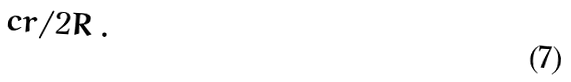Convert formula to latex. <formula><loc_0><loc_0><loc_500><loc_500>c r / 2 R \, .</formula> 